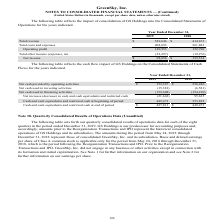From Greensky's financial document, Which years does the table show? The document shows two values: 2019 and 2018. From the document: "Year Ended December 31, 2019 2018 Year Ended December 31, 2019 2018..." Also, What was the Net cash provided by operating activities in 2019? According to the financial document, 153,327 (in thousands). The relevant text states: "2018 Net cash provided by operating activities $ 153,327 $ 256,426 Net cash used in investing activities (15,381) (6,581) Net cash used in financing activit..." Also, What was the Net cash used in financing activities in 2019? According to the financial document, (159,608) (in thousands). The relevant text states: "381) (6,581) Net cash used in financing activities (159,608) (154,210) Net increase (decrease) in cash and cash equivalents and restricted cash (21,662) 95,635 C..." Also, Which years did Cash and cash equivalents and restricted cash at beginning of period exceed $400,000 thousand? Based on the analysis, there are 1 instances. The counting process: 2019. Also, can you calculate: What was the change in the net cash used in financing activities between 2018 and 2019? Based on the calculation: -159,608-(-154,210), the result is -5398 (in thousands). This is based on the information: "Net cash used in financing activities (159,608) (154,210) Net increase (decrease) in cash and cash equivalents and restricted cash (21,662) 95,635 Cash and 1) (6,581) Net cash used in financing activi..." The key data points involved are: 154,210, 159,608. Also, can you calculate: What was the percentage change in Net cash provided by operating activities between 2018 and 2019? To answer this question, I need to perform calculations using the financial data. The calculation is: (153,327-256,426)/256,426, which equals -40.21 (percentage). This is based on the information: "cash provided by operating activities $ 153,327 $ 256,426 Net cash used in investing activities (15,381) (6,581) Net cash used in financing activities (159,6 2018 Net cash provided by operating activi..." The key data points involved are: 153,327, 256,426. 